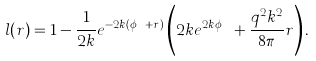Convert formula to latex. <formula><loc_0><loc_0><loc_500><loc_500>l ( r ) = 1 - \frac { 1 } { 2 k } e ^ { - 2 k ( \phi _ { H } + r ) } \left ( 2 k e ^ { 2 k \phi _ { H } } + \frac { q ^ { 2 } k ^ { 2 } } { 8 \pi } r \right ) .</formula> 